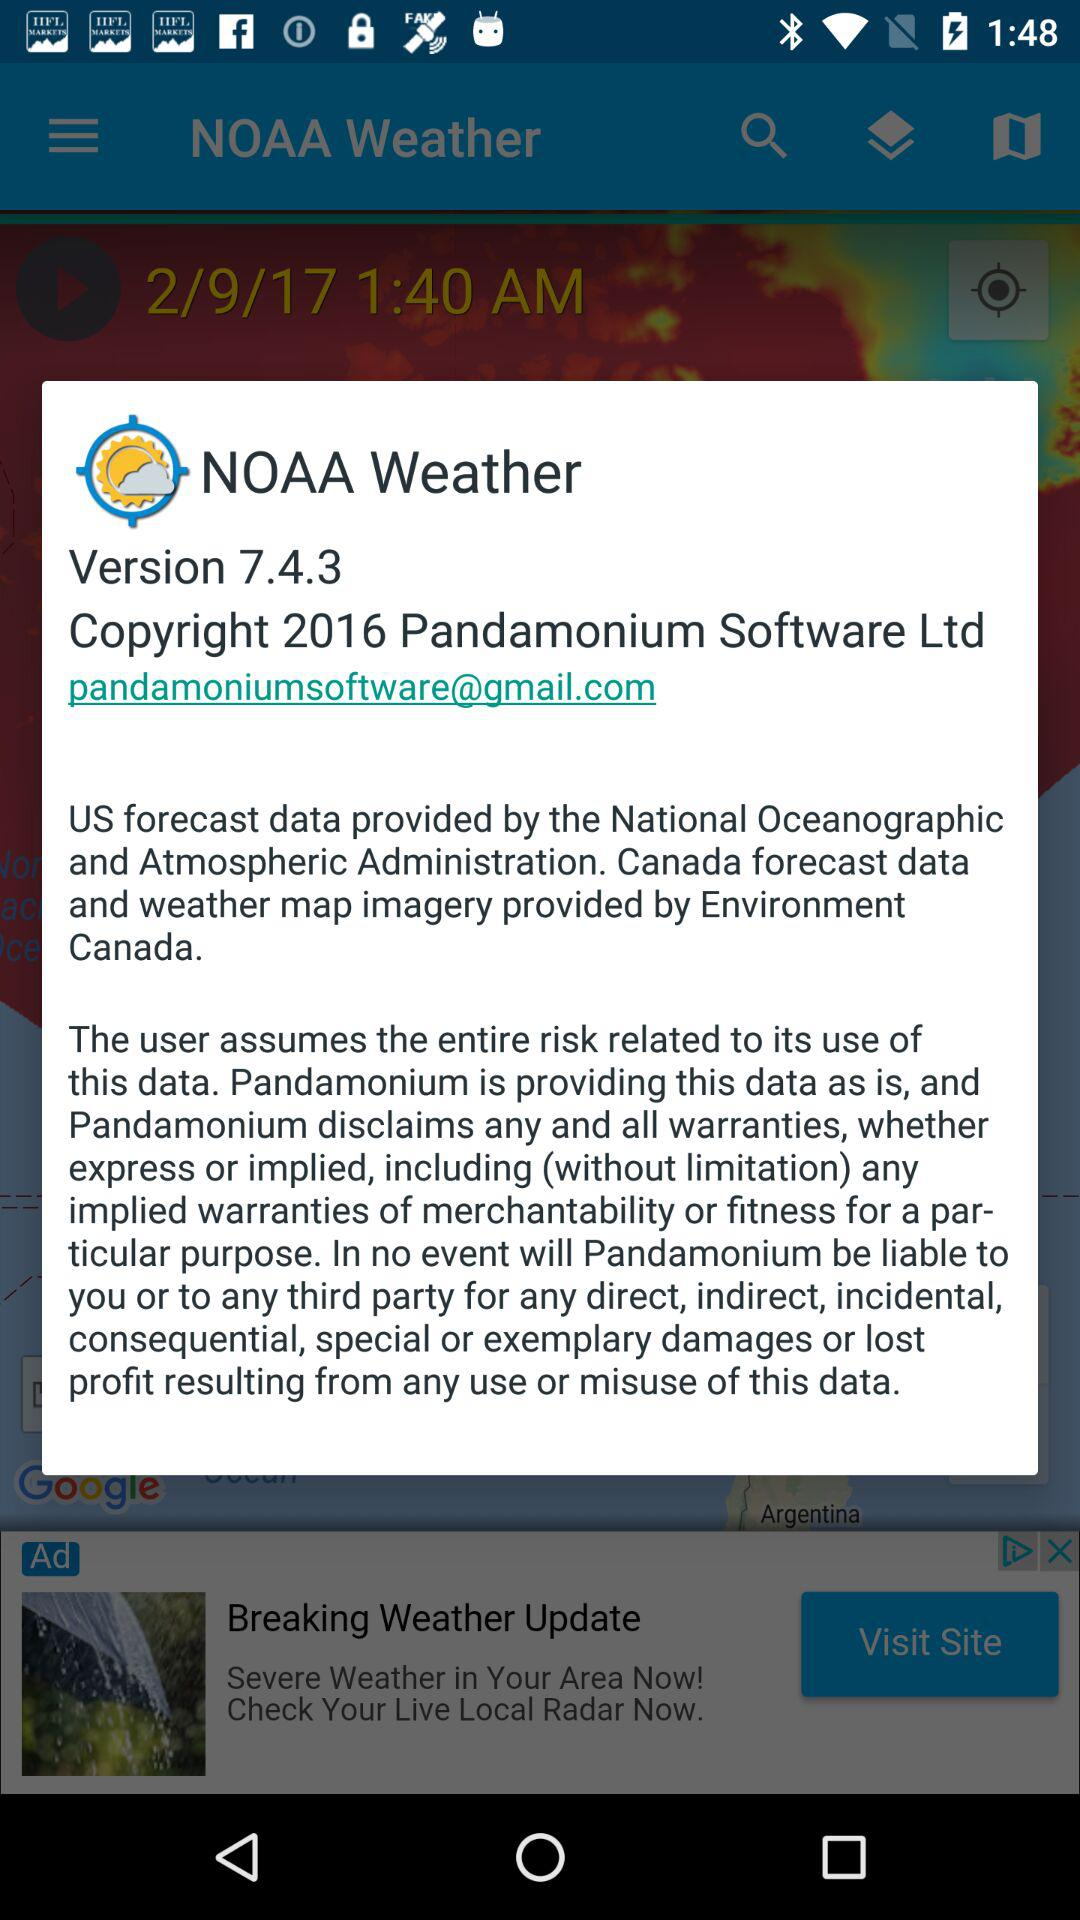What is the app name? The app name is "NOAA Weather". 